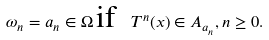Convert formula to latex. <formula><loc_0><loc_0><loc_500><loc_500>\omega _ { n } = a _ { n } \in \Omega \, \text {if\ \ } T ^ { n } ( x ) \in A _ { a _ { n } } , n \geq 0 .</formula> 